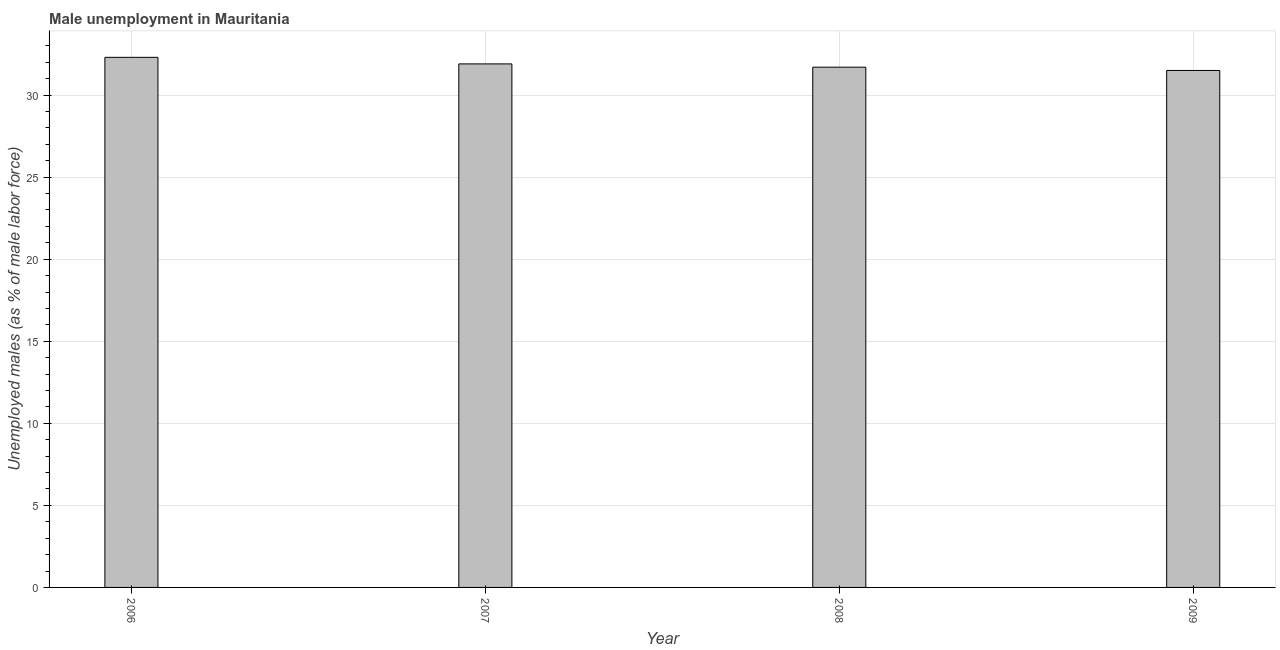Does the graph contain any zero values?
Ensure brevity in your answer.  No. Does the graph contain grids?
Your answer should be very brief. Yes. What is the title of the graph?
Offer a very short reply. Male unemployment in Mauritania. What is the label or title of the Y-axis?
Your answer should be compact. Unemployed males (as % of male labor force). What is the unemployed males population in 2009?
Keep it short and to the point. 31.5. Across all years, what is the maximum unemployed males population?
Provide a short and direct response. 32.3. Across all years, what is the minimum unemployed males population?
Ensure brevity in your answer.  31.5. In which year was the unemployed males population maximum?
Your answer should be compact. 2006. In which year was the unemployed males population minimum?
Give a very brief answer. 2009. What is the sum of the unemployed males population?
Your response must be concise. 127.4. What is the average unemployed males population per year?
Provide a succinct answer. 31.85. What is the median unemployed males population?
Make the answer very short. 31.8. In how many years, is the unemployed males population greater than 10 %?
Ensure brevity in your answer.  4. Do a majority of the years between 2008 and 2006 (inclusive) have unemployed males population greater than 6 %?
Your response must be concise. Yes. What is the ratio of the unemployed males population in 2006 to that in 2008?
Keep it short and to the point. 1.02. Is the unemployed males population in 2007 less than that in 2008?
Offer a terse response. No. Is the difference between the unemployed males population in 2006 and 2009 greater than the difference between any two years?
Provide a succinct answer. Yes. Are all the bars in the graph horizontal?
Offer a very short reply. No. Are the values on the major ticks of Y-axis written in scientific E-notation?
Provide a short and direct response. No. What is the Unemployed males (as % of male labor force) in 2006?
Keep it short and to the point. 32.3. What is the Unemployed males (as % of male labor force) in 2007?
Your answer should be compact. 31.9. What is the Unemployed males (as % of male labor force) in 2008?
Make the answer very short. 31.7. What is the Unemployed males (as % of male labor force) of 2009?
Your answer should be compact. 31.5. What is the difference between the Unemployed males (as % of male labor force) in 2006 and 2009?
Ensure brevity in your answer.  0.8. What is the difference between the Unemployed males (as % of male labor force) in 2007 and 2008?
Keep it short and to the point. 0.2. What is the difference between the Unemployed males (as % of male labor force) in 2007 and 2009?
Ensure brevity in your answer.  0.4. What is the ratio of the Unemployed males (as % of male labor force) in 2006 to that in 2007?
Offer a very short reply. 1.01. What is the ratio of the Unemployed males (as % of male labor force) in 2006 to that in 2008?
Offer a very short reply. 1.02. What is the ratio of the Unemployed males (as % of male labor force) in 2006 to that in 2009?
Offer a terse response. 1.02. What is the ratio of the Unemployed males (as % of male labor force) in 2007 to that in 2008?
Make the answer very short. 1.01. What is the ratio of the Unemployed males (as % of male labor force) in 2007 to that in 2009?
Your answer should be very brief. 1.01. 